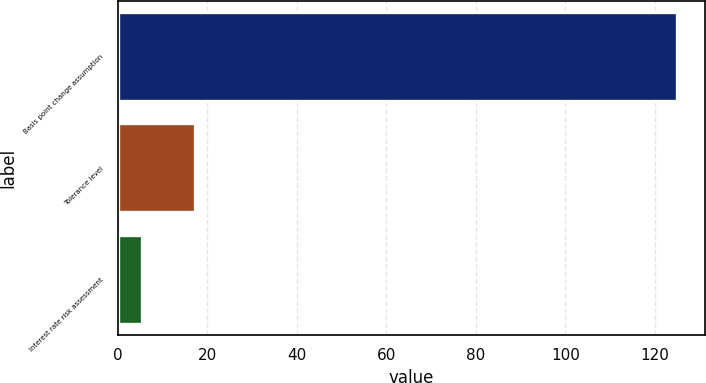<chart> <loc_0><loc_0><loc_500><loc_500><bar_chart><fcel>Basis point change assumption<fcel>Tolerance level<fcel>Interest rate risk assessment<nl><fcel>125<fcel>17.32<fcel>5.35<nl></chart> 